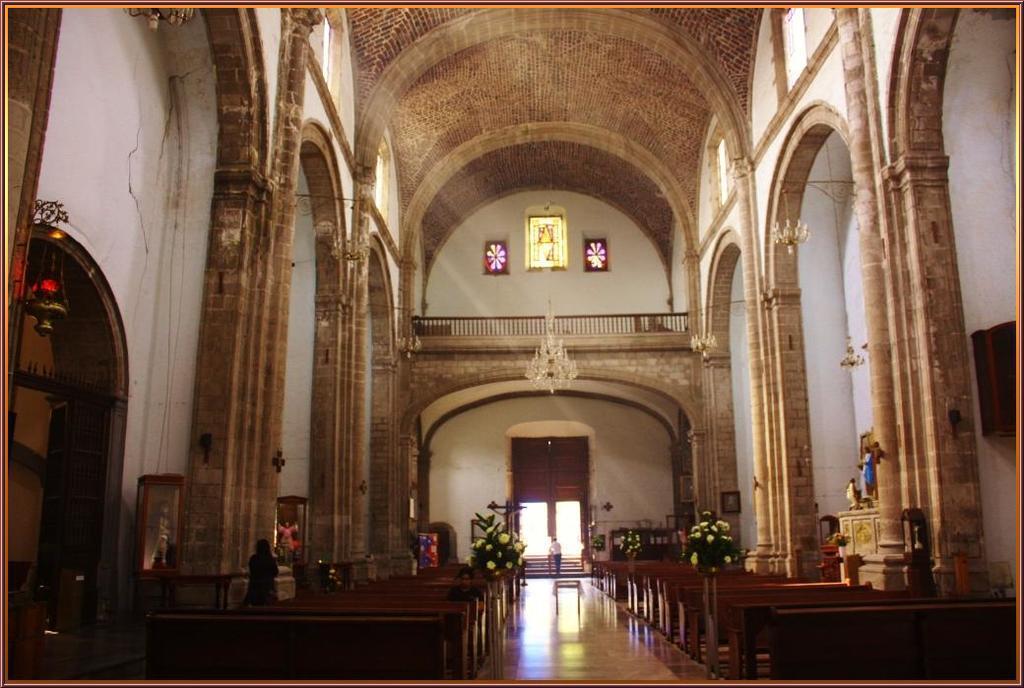In one or two sentences, can you explain what this image depicts? This is an inside view of a building and here we can see flower pots, benches, some people, statues, ceiling lights and stands and there is a wall. At the bottom, there is a floor. 